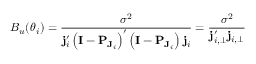<formula> <loc_0><loc_0><loc_500><loc_500>B _ { u } ( \boldsymbol \theta _ { i } ) = \frac { \sigma ^ { 2 } } { j _ { i } ^ { \prime } \left ( I - P _ { J _ { i } } \right ) ^ { \prime } \left ( I - P _ { J _ { i } } \right ) j _ { i } } = \frac { \sigma ^ { 2 } } { j _ { i , \perp } ^ { \prime } j _ { i , \perp } }</formula> 